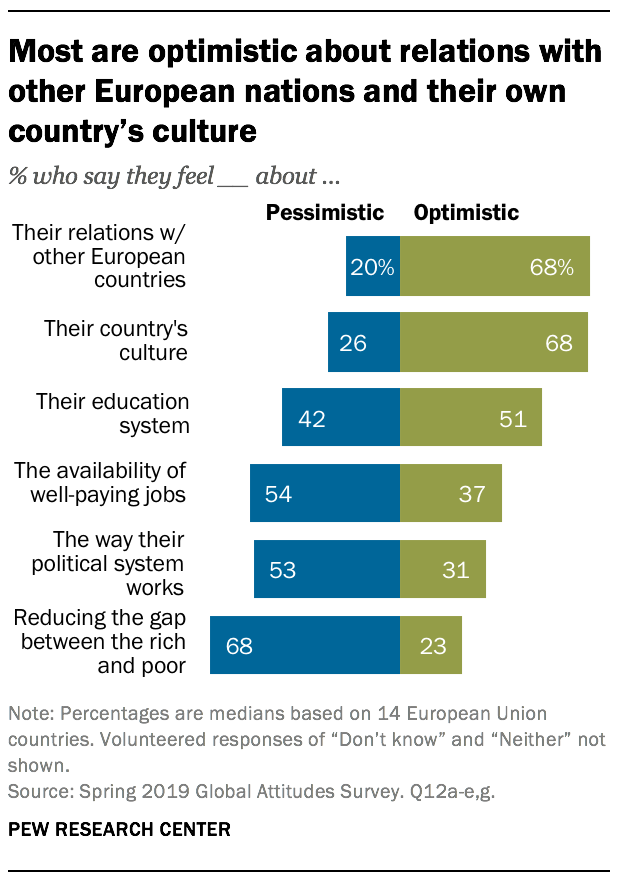Mention a couple of crucial points in this snapshot. The lowest value on the blue bar is 0.2. The average of all the values on green bars is 46.33. 